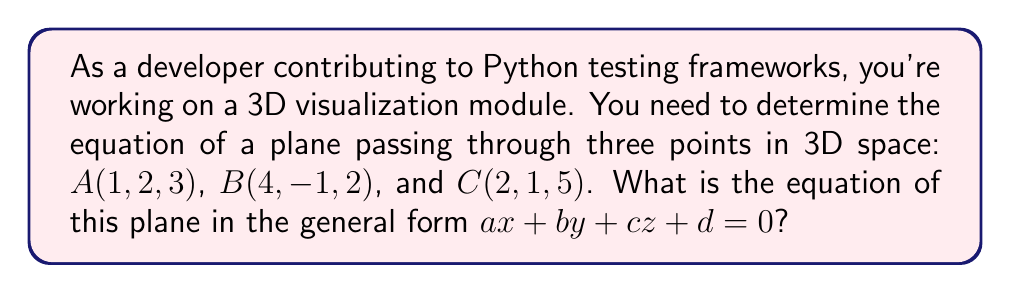Can you answer this question? To find the equation of a plane passing through three points, we'll follow these steps:

1) First, we need to find two vectors on the plane. We can do this by subtracting the coordinates of two points from the third:

   $\vec{AB} = B - A = (4-1, -1-2, 2-3) = (3, -3, -1)$
   $\vec{AC} = C - A = (2-1, 1-2, 5-3) = (1, -1, 2)$

2) The normal vector to the plane will be the cross product of these two vectors:

   $\vec{n} = \vec{AB} \times \vec{AC} = \begin{vmatrix} 
   i & j & k \\
   3 & -3 & -1 \\
   1 & -1 & 2
   \end{vmatrix}$

   $= (-3(2) - (-1)(-1))i - (3(2) - (-1)(1))j + (3(-1) - (-3)(1))k$
   $= (-6 + 1)i - (6 - (-1))j + (-3 - (-3))k$
   $= -5i - 7j + 0k = (-5, -7, 0)$

3) The general equation of a plane is $ax + by + cz + d = 0$, where $(a, b, c)$ is the normal vector. So our equation will be of the form:

   $-5x - 7y + 0z + d = 0$

4) To find $d$, we can substitute the coordinates of any of the given points. Let's use $A(1, 2, 3)$:

   $-5(1) - 7(2) + 0(3) + d = 0$
   $-5 - 14 + d = 0$
   $d = 19$

5) Therefore, the equation of the plane is:

   $-5x - 7y + 0z + 19 = 0$

6) Simplifying by removing the zero term:

   $-5x - 7y + 19 = 0$
Answer: $-5x - 7y + 19 = 0$ 